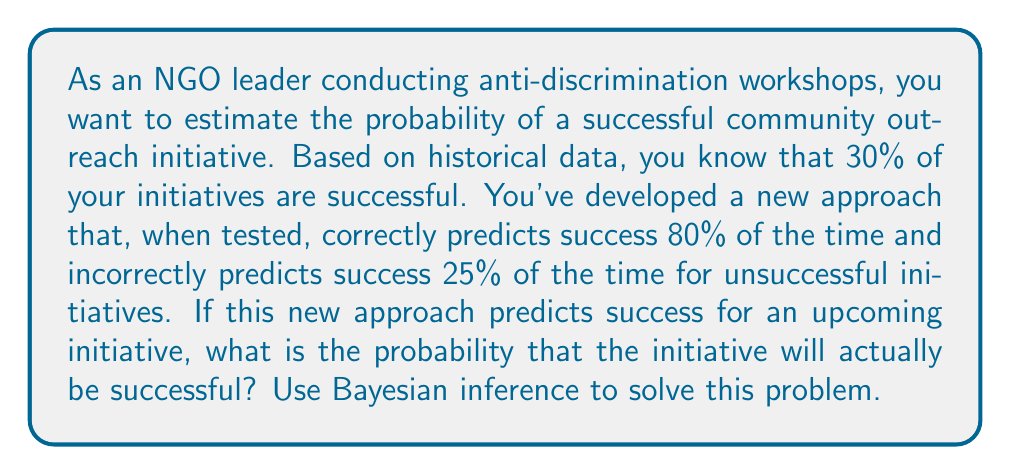Could you help me with this problem? Let's approach this step-by-step using Bayesian inference:

1) Define our events:
   S: The initiative is successful
   P: The new approach predicts success

2) Given information:
   P(S) = 0.30 (prior probability of success)
   P(P|S) = 0.80 (probability of predicting success given that it is actually successful)
   P(P|not S) = 0.25 (probability of predicting success given that it is actually unsuccessful)

3) We want to find P(S|P) using Bayes' theorem:

   $$P(S|P) = \frac{P(P|S) \cdot P(S)}{P(P)}$$

4) We need to calculate P(P) using the law of total probability:

   $$P(P) = P(P|S) \cdot P(S) + P(P|not S) \cdot P(not S)$$

5) Calculate P(not S):
   P(not S) = 1 - P(S) = 1 - 0.30 = 0.70

6) Now we can calculate P(P):
   $$P(P) = 0.80 \cdot 0.30 + 0.25 \cdot 0.70 = 0.24 + 0.175 = 0.415$$

7) Finally, we can apply Bayes' theorem:

   $$P(S|P) = \frac{0.80 \cdot 0.30}{0.415} = \frac{0.24}{0.415} \approx 0.5783$$

Therefore, the probability that the initiative will actually be successful, given that the new approach predicts success, is approximately 0.5783 or 57.83%.
Answer: 0.5783 